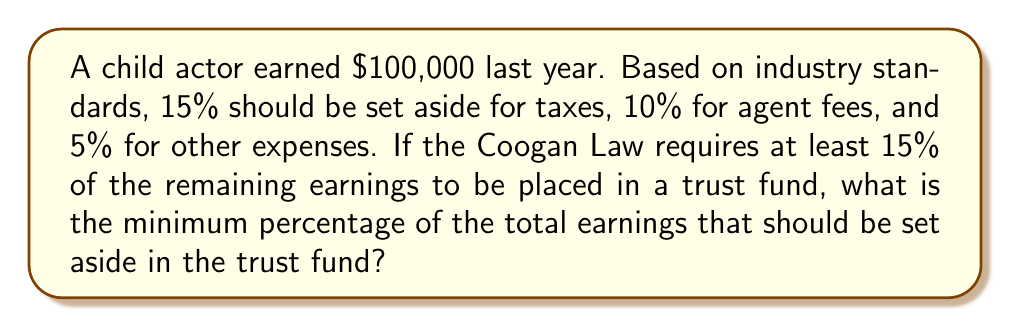Help me with this question. Let's approach this step-by-step:

1) First, calculate the total deductions:
   Taxes: 15%
   Agent fees: 10%
   Other expenses: 5%
   Total deductions: $15\% + 10\% + 5\% = 30\%$

2) The remaining earnings after deductions:
   $100\% - 30\% = 70\%$ of the total earnings

3) The Coogan Law requires at least 15% of the remaining earnings to be placed in a trust fund. To calculate this as a percentage of the total earnings:

   $15\% \text{ of } 70\% = 0.15 \times 0.70 = 0.105 = 10.5\%$

4) Therefore, the minimum percentage of the total earnings that should be set aside in the trust fund is 10.5%.

To verify:
$\frac{\text{Trust fund amount}}{\text{Total earnings}} = \frac{10.5}{100} = 0.105$

This is equivalent to 15% of the remaining 70%:
$\frac{0.15 \times 70}{100} = 0.105$
Answer: 10.5% 